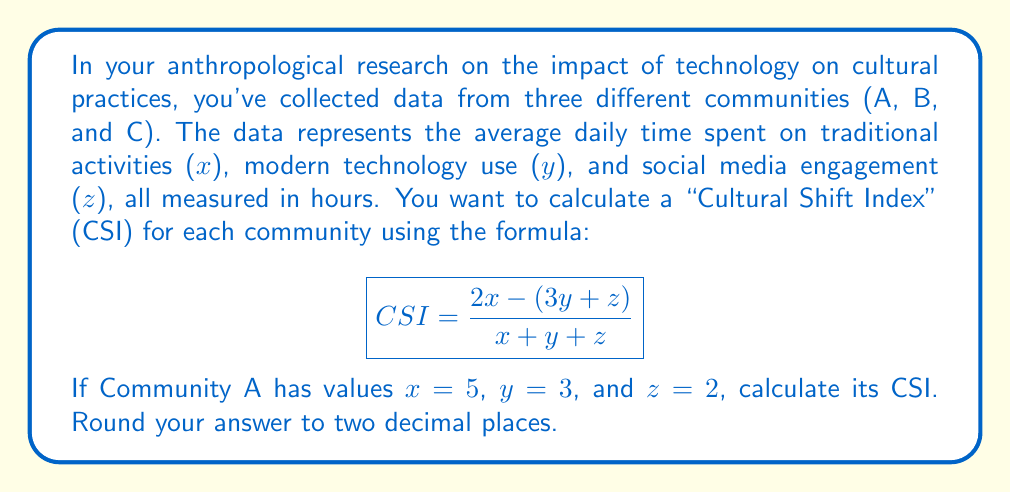Can you solve this math problem? To solve this problem, we'll use the order of operations (PEMDAS: Parentheses, Exponents, Multiplication/Division, Addition/Subtraction) to calculate the CSI for Community A.

Given:
$x = 5$, $y = 3$, and $z = 2$

Step 1: Substitute the values into the formula.
$$ CSI = \frac{2(5) - (3(3) + 2)}{5 + 3 + 2} $$

Step 2: Solve operations within parentheses.
$$ CSI = \frac{2(5) - (9 + 2)}{5 + 3 + 2} $$

Step 3: Perform multiplication.
$$ CSI = \frac{10 - (11)}{5 + 3 + 2} $$

Step 4: Solve the remaining operations in the numerator and denominator.
$$ CSI = \frac{10 - 11}{10} $$
$$ CSI = \frac{-1}{10} $$

Step 5: Perform the division and round to two decimal places.
$$ CSI = -0.10 $$

Therefore, the Cultural Shift Index for Community A is -0.10.
Answer: -0.10 